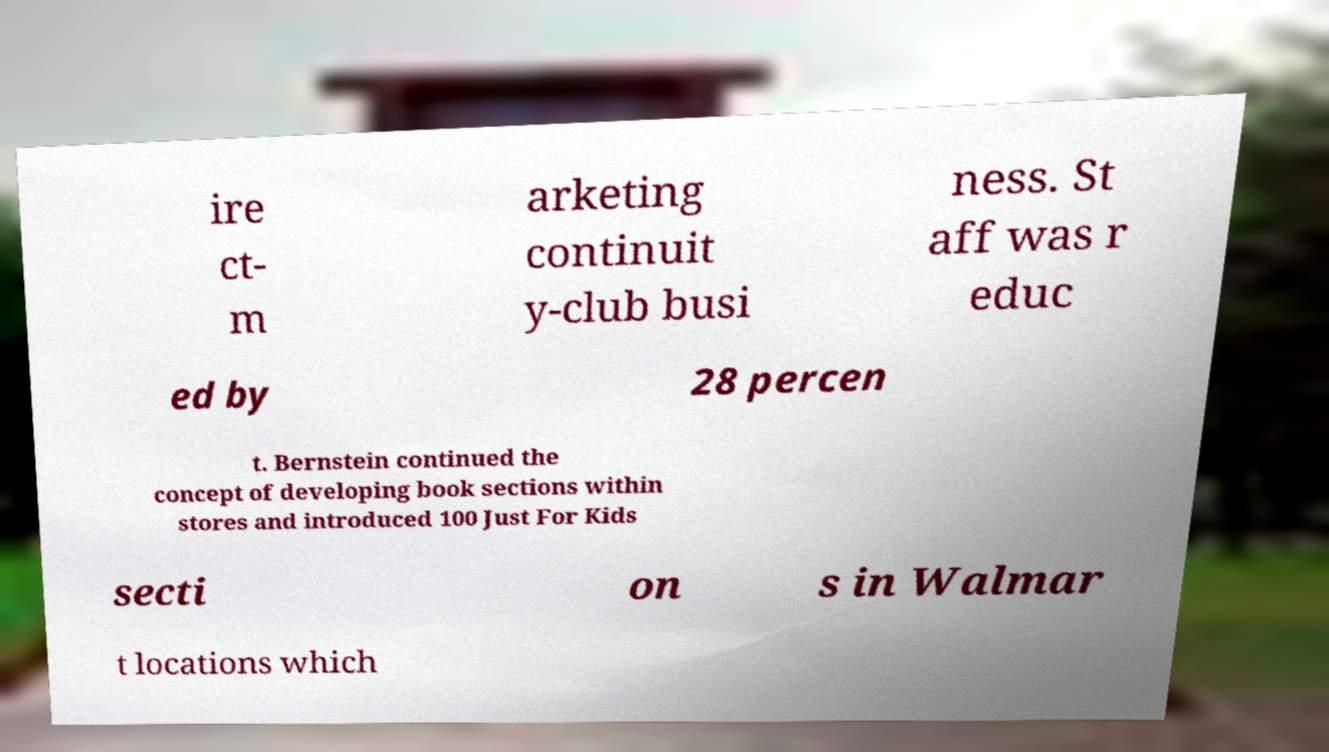Please identify and transcribe the text found in this image. ire ct- m arketing continuit y-club busi ness. St aff was r educ ed by 28 percen t. Bernstein continued the concept of developing book sections within stores and introduced 100 Just For Kids secti on s in Walmar t locations which 